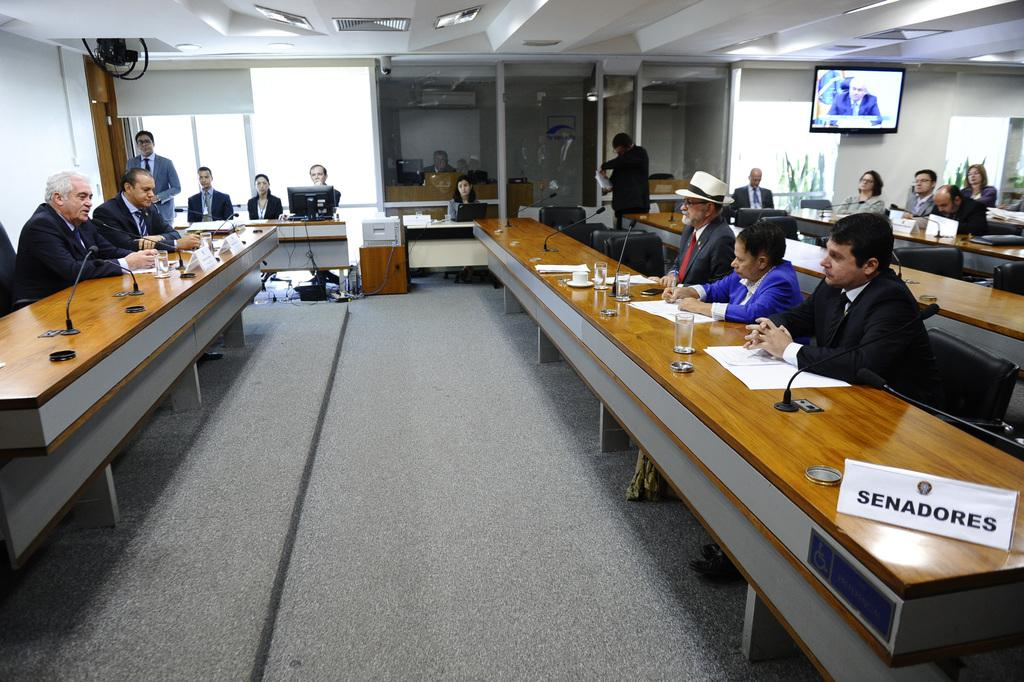What is the color of the wall in the image? The wall in the image is white. What can be seen on the wall in the image? There is a screen on the wall in the image. What are the people in the image doing? The people in the image are sitting on chairs. What is on the table in the image? There are glasses, mics, and papers on the table in the image. Can you tell me how many insects are crawling on the screen in the image? There are no insects present on the screen in the image. What type of prose is being read by the people in the image? There is no indication of any prose being read in the image; the people are sitting on chairs and there are papers on the table, but no specific text is mentioned. 